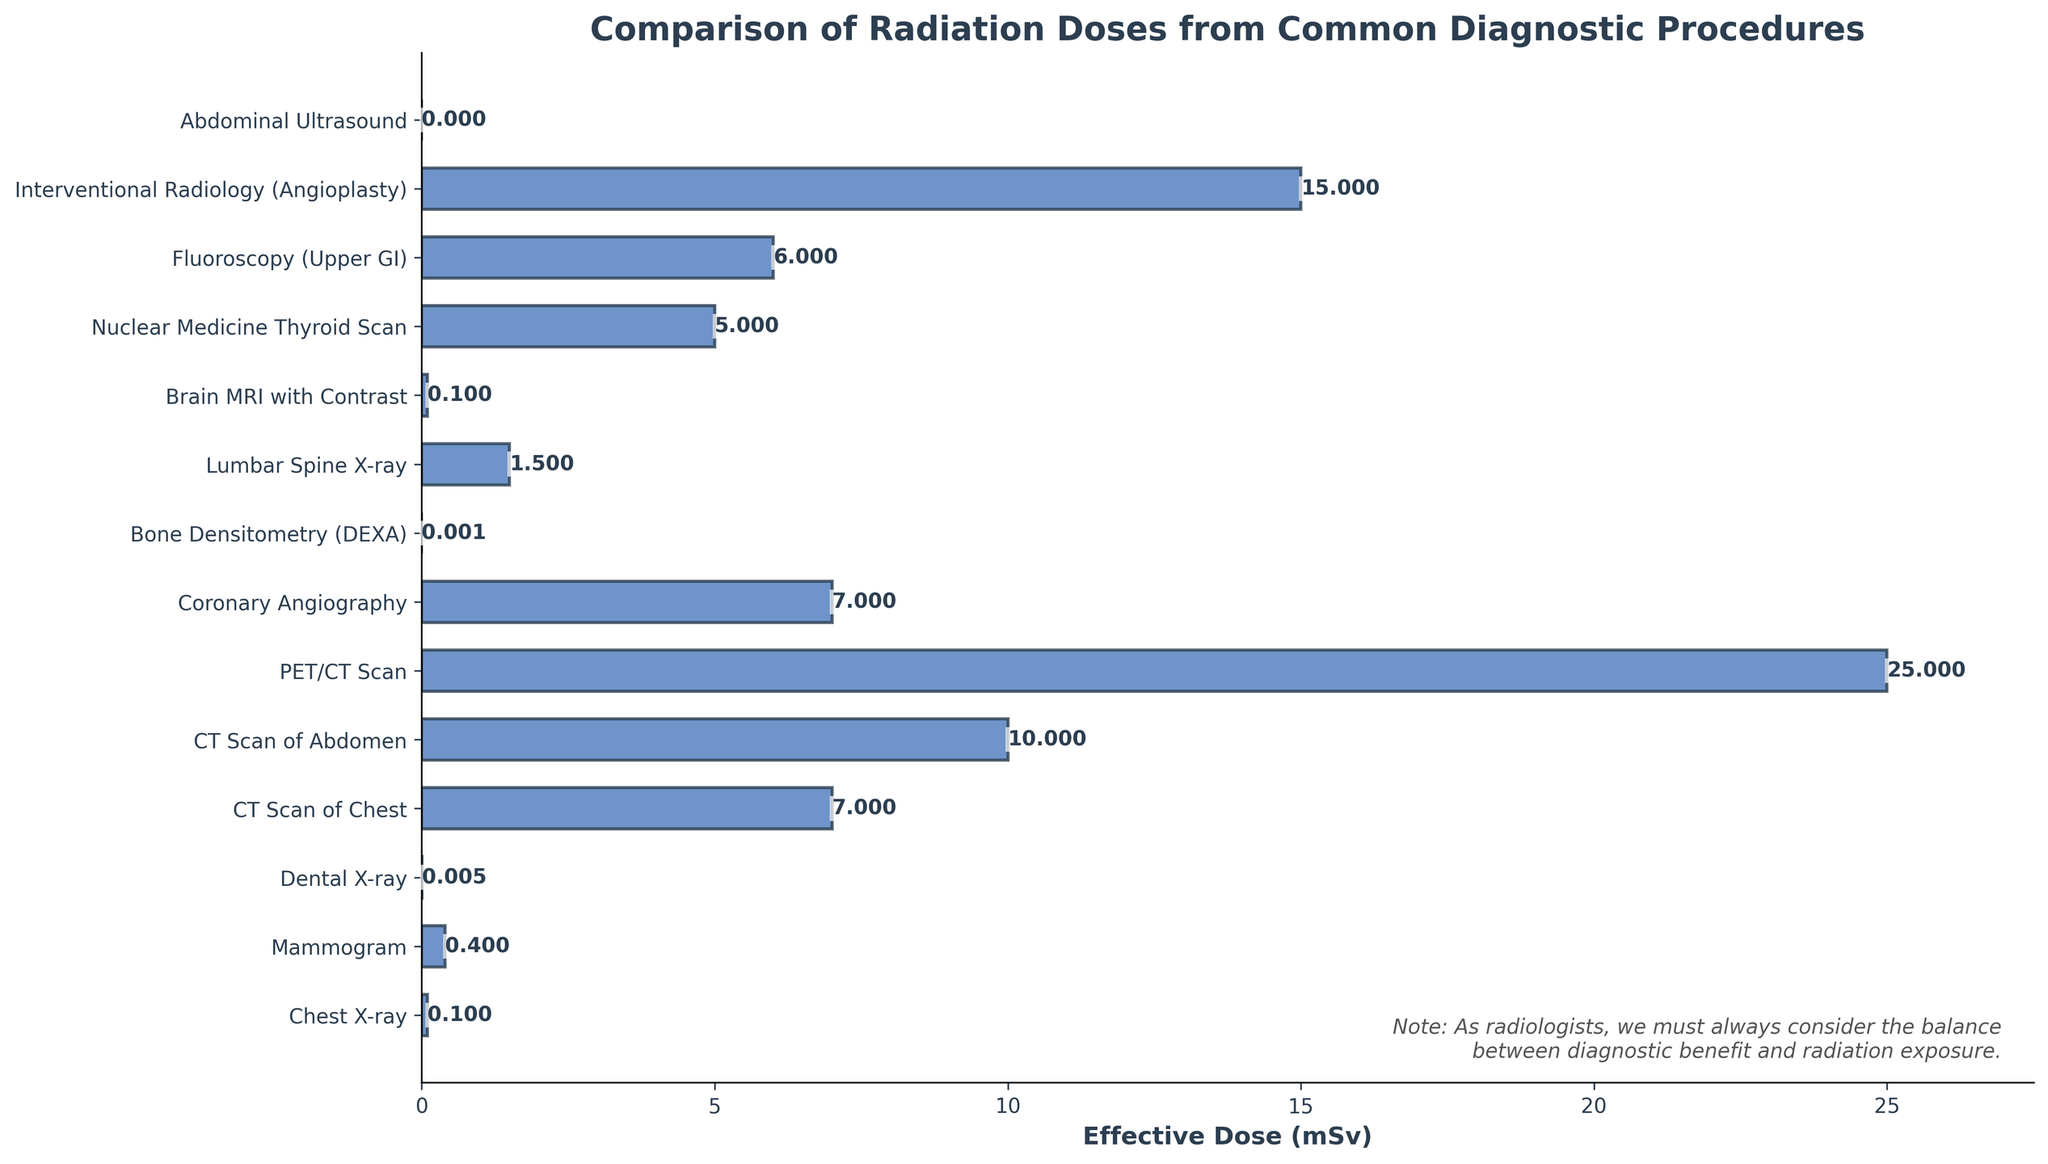Which diagnostic procedure has the highest effective dose? By examining the length of the bars in the horizontal bar chart, we can see that the PET/CT Scan has the longest bar, indicating the highest effective dose.
Answer: PET/CT Scan How much higher is the effective dose of an Interventional Radiology (Angioplasty) compared to a Chest X-ray? First, identify the effective dose of Interventional Radiology (Angioplasty) which is 15 mSv, and that of a Chest X-ray is 0.1 mSv. Then, subtract the dose of the Chest X-ray from the dose of the Interventional Radiology (Angioplasty): 15 - 0.1 = 14.9 mSv.
Answer: 14.9 mSv Which diagnostic procedure has an effective dose closest to 1 mSv? By examining the lengths of the bars and their corresponding labels, the Lumbar Spine X-ray has an effective dose of 1.5 mSv, which is the closest to 1 mSv.
Answer: Lumbar Spine X-ray Which procedures have effective doses less than 1 mSv? Checking the figure, the procedures with bars that are shorter or equal to the bar representing 1 mSv are: Chest X-ray, Mammogram, Dental X-ray, Bone Densitometry (DEXA), Brain MRI with Contrast, and Abdominal Ultrasound.
Answer: Chest X-ray, Mammogram, Dental X-ray, Bone Densitometry (DEXA), Brain MRI with Contrast, Abdominal Ultrasound What is the sum of the effective doses from a Dental X-ray, Bone Densitometry (DEXA), and Brain MRI with Contrast? Find the effective doses for the three procedures (0.005 mSv for Dental X-ray, 0.001 mSv for Bone Densitometry (DEXA), and 0.1 mSv for Brain MRI with Contrast), and sum them: 0.005 + 0.001 + 0.1 = 0.106 mSv.
Answer: 0.106 mSv Which has a higher effective dose, a Fluoroscopy (Upper GI) or a CT Scan of Chest? Identify the effective doses for Fluoroscopy (Upper GI) which is 6 mSv, and for CT Scan of Chest which is 7 mSv. Compare the two values: 7 mSv is greater than 6 mSv.
Answer: CT Scan of Chest What is the average effective dose for the procedures: Nuclear Medicine Thyroid Scan, Coronary Angiography, and Fluoroscopy (Upper GI)? Identify the effective doses: 5 mSv for Nuclear Medicine Thyroid Scan, 7 mSv for Coronary Angiography, and 6 mSv for Fluoroscopy (Upper GI). Sum these values: 5 + 7 + 6 = 18 mSv. Then divide by the number of procedures: 18 / 3 = 6 mSv.
Answer: 6 mSv Is the effective dose of a Mammogram greater than that of a Chest X-ray? Check the bars corresponding to each procedure. The effective dose of a Mammogram is 0.4 mSv, and that of a Chest X-ray is 0.1 mSv. As 0.4 is greater than 0.1, the answer is yes.
Answer: Yes Which procedure has the smallest effective dose and what is its value? By comparing the lengths of the bars, the Bone Densitometry (DEXA) has the shortest bar, indicative of the smallest effective dose which is 0.001 mSv.
Answer: Bone Densitometry (DEXA), 0.001 mSv How many procedures have an effective dose of 10 mSv or higher? From the figure, count the procedures with bars longer than or equal to the bar representing 10 mSv: CT Scan of Abdomen (10 mSv), PET/CT Scan (25 mSv), and Interventional Radiology (Angioplasty) (15 mSv). There are 3 procedures.
Answer: 3 